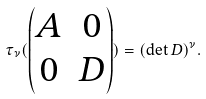<formula> <loc_0><loc_0><loc_500><loc_500>\tau _ { \nu } ( \begin{pmatrix} A & 0 \\ 0 & D \end{pmatrix} ) = ( \det D ) ^ { \nu } .</formula> 